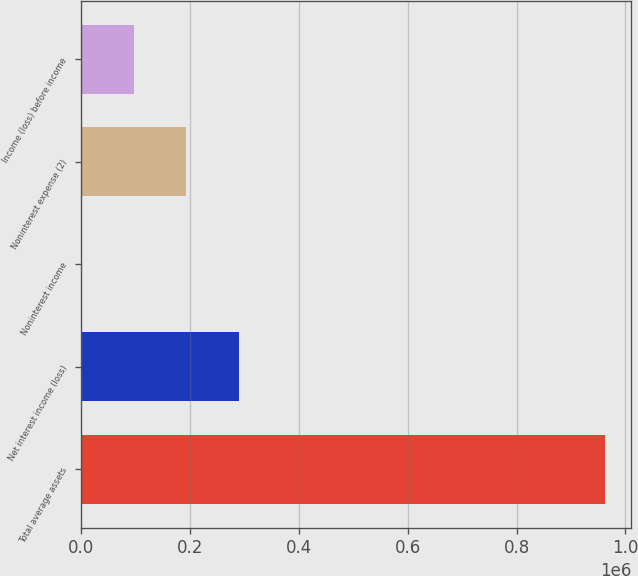Convert chart. <chart><loc_0><loc_0><loc_500><loc_500><bar_chart><fcel>Total average assets<fcel>Net interest income (loss)<fcel>Noninterest income<fcel>Noninterest expense (2)<fcel>Income (loss) before income<nl><fcel>962701<fcel>289981<fcel>1673<fcel>193879<fcel>97775.8<nl></chart> 